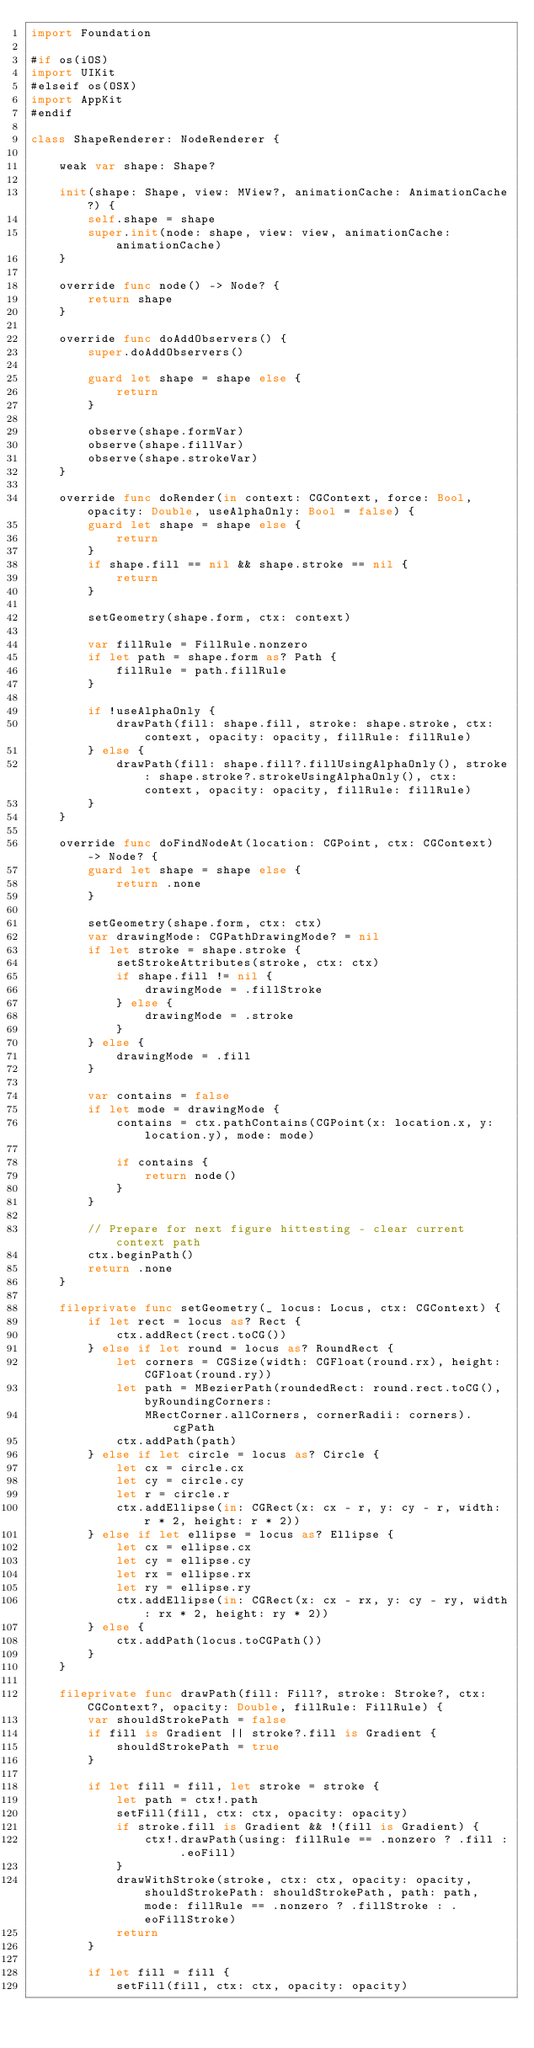<code> <loc_0><loc_0><loc_500><loc_500><_Swift_>import Foundation

#if os(iOS)
import UIKit
#elseif os(OSX)
import AppKit
#endif

class ShapeRenderer: NodeRenderer {

    weak var shape: Shape?

    init(shape: Shape, view: MView?, animationCache: AnimationCache?) {
        self.shape = shape
        super.init(node: shape, view: view, animationCache: animationCache)
    }

    override func node() -> Node? {
        return shape
    }

    override func doAddObservers() {
        super.doAddObservers()

        guard let shape = shape else {
            return
        }

        observe(shape.formVar)
        observe(shape.fillVar)
        observe(shape.strokeVar)
    }

    override func doRender(in context: CGContext, force: Bool, opacity: Double, useAlphaOnly: Bool = false) {
        guard let shape = shape else {
            return
        }
        if shape.fill == nil && shape.stroke == nil {
            return
        }

        setGeometry(shape.form, ctx: context)

        var fillRule = FillRule.nonzero
        if let path = shape.form as? Path {
            fillRule = path.fillRule
        }

        if !useAlphaOnly {
            drawPath(fill: shape.fill, stroke: shape.stroke, ctx: context, opacity: opacity, fillRule: fillRule)
        } else {
            drawPath(fill: shape.fill?.fillUsingAlphaOnly(), stroke: shape.stroke?.strokeUsingAlphaOnly(), ctx: context, opacity: opacity, fillRule: fillRule)
        }
    }

    override func doFindNodeAt(location: CGPoint, ctx: CGContext) -> Node? {
        guard let shape = shape else {
            return .none
        }

        setGeometry(shape.form, ctx: ctx)
        var drawingMode: CGPathDrawingMode? = nil
        if let stroke = shape.stroke {
            setStrokeAttributes(stroke, ctx: ctx)
            if shape.fill != nil {
                drawingMode = .fillStroke
            } else {
                drawingMode = .stroke
            }
        } else {
            drawingMode = .fill
        }

        var contains = false
        if let mode = drawingMode {
            contains = ctx.pathContains(CGPoint(x: location.x, y: location.y), mode: mode)

            if contains {
                return node()
            }
        }

        // Prepare for next figure hittesting - clear current context path
        ctx.beginPath()
        return .none
    }

    fileprivate func setGeometry(_ locus: Locus, ctx: CGContext) {
        if let rect = locus as? Rect {
            ctx.addRect(rect.toCG())
        } else if let round = locus as? RoundRect {
            let corners = CGSize(width: CGFloat(round.rx), height: CGFloat(round.ry))
            let path = MBezierPath(roundedRect: round.rect.toCG(), byRoundingCorners:
                MRectCorner.allCorners, cornerRadii: corners).cgPath
            ctx.addPath(path)
        } else if let circle = locus as? Circle {
            let cx = circle.cx
            let cy = circle.cy
            let r = circle.r
            ctx.addEllipse(in: CGRect(x: cx - r, y: cy - r, width: r * 2, height: r * 2))
        } else if let ellipse = locus as? Ellipse {
            let cx = ellipse.cx
            let cy = ellipse.cy
            let rx = ellipse.rx
            let ry = ellipse.ry
            ctx.addEllipse(in: CGRect(x: cx - rx, y: cy - ry, width: rx * 2, height: ry * 2))
        } else {
            ctx.addPath(locus.toCGPath())
        }
    }

    fileprivate func drawPath(fill: Fill?, stroke: Stroke?, ctx: CGContext?, opacity: Double, fillRule: FillRule) {
        var shouldStrokePath = false
        if fill is Gradient || stroke?.fill is Gradient {
            shouldStrokePath = true
        }

        if let fill = fill, let stroke = stroke {
            let path = ctx!.path
            setFill(fill, ctx: ctx, opacity: opacity)
            if stroke.fill is Gradient && !(fill is Gradient) {
                ctx!.drawPath(using: fillRule == .nonzero ? .fill : .eoFill)
            }
            drawWithStroke(stroke, ctx: ctx, opacity: opacity, shouldStrokePath: shouldStrokePath, path: path, mode: fillRule == .nonzero ? .fillStroke : .eoFillStroke)
            return
        }

        if let fill = fill {
            setFill(fill, ctx: ctx, opacity: opacity)</code> 